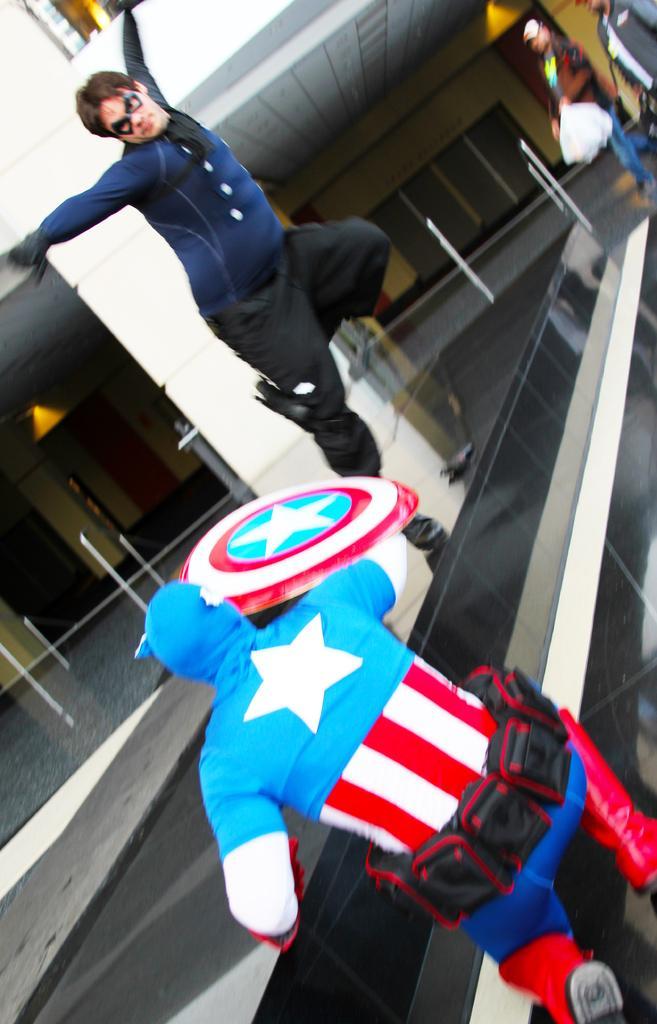Could you give a brief overview of what you see in this image? Here in this picture in the front we can see two men wearing costumes on them and the person in the front is sitting with a shield in his hand and the other person is jumping onto him and behind them also we can see other people standing and watching them and behind them we can see a building present over there. 